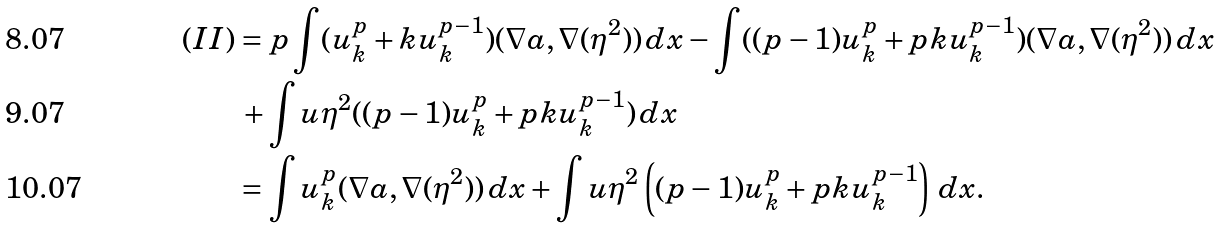Convert formula to latex. <formula><loc_0><loc_0><loc_500><loc_500>( I I ) & = p \int ( u _ { k } ^ { p } + k u _ { k } ^ { p - 1 } ) ( \nabla a , \nabla ( \eta ^ { 2 } ) ) \, d x - \int ( ( p - 1 ) u _ { k } ^ { p } + p k u _ { k } ^ { p - 1 } ) ( \nabla a , \nabla ( \eta ^ { 2 } ) ) \, d x \\ & \, + \int u \eta ^ { 2 } ( ( p - 1 ) u _ { k } ^ { p } + p k u _ { k } ^ { p - 1 } ) \, d x \\ & = \int u _ { k } ^ { p } ( \nabla a , \nabla ( \eta ^ { 2 } ) ) \, d x + \int u \eta ^ { 2 } \left ( ( p - 1 ) u _ { k } ^ { p } + p k u _ { k } ^ { p - 1 } \right ) \, d x .</formula> 